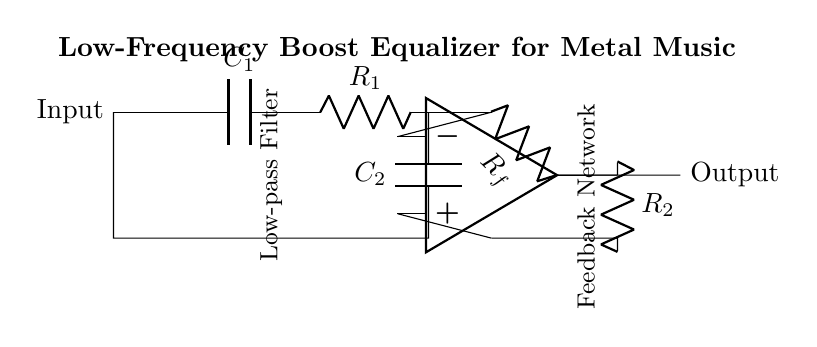What component is used to boost low frequencies? The low-frequency boost in this circuit is achieved by using a low-pass filter, which consists of the resistor and capacitor configuration.
Answer: Low-pass filter What is the role of the op-amp in this circuit? The operational amplifier (op-amp) is used to amplify the signal after it's been filtered by the low-pass filter to enhance the low-frequency response.
Answer: Amplification What values do R1 and C1 represent? R1 is a resistor in the low-pass filter, and C1 is a capacitor that works with R1 to filter out higher frequencies.
Answer: Resistor and capacitor How many resistors are present in this circuit? There are three resistors present in the circuit: R1, R2, and Rf.
Answer: Three What connects the output of the op-amp back to the circuit? The feedback network composed of R2 connects the output of the op-amp back to its inverting input to control the gain.
Answer: R2 Which component plays a crucial role in the feedback mechanism? The resistor R2 plays a crucial role in the feedback mechanism to set the gain of the op-amp stage.
Answer: R2 What is the purpose of C2 in the circuit? C2 functions as part of the low-pass filter, allowing low frequencies to pass while blocking higher frequencies.
Answer: Low-pass filter 